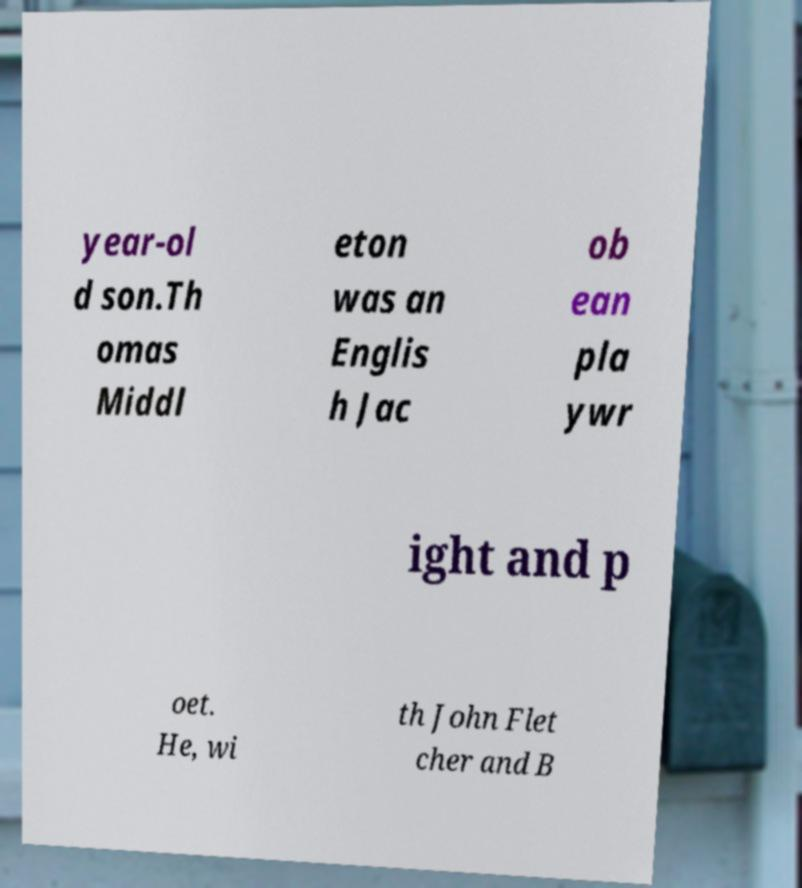Could you assist in decoding the text presented in this image and type it out clearly? year-ol d son.Th omas Middl eton was an Englis h Jac ob ean pla ywr ight and p oet. He, wi th John Flet cher and B 